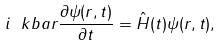Convert formula to latex. <formula><loc_0><loc_0><loc_500><loc_500>i \ k b a r \frac { \partial \psi ( { r } \/ , t ) } { \partial t } = \hat { H } ( t ) \psi ( { r } \/ , t ) ,</formula> 